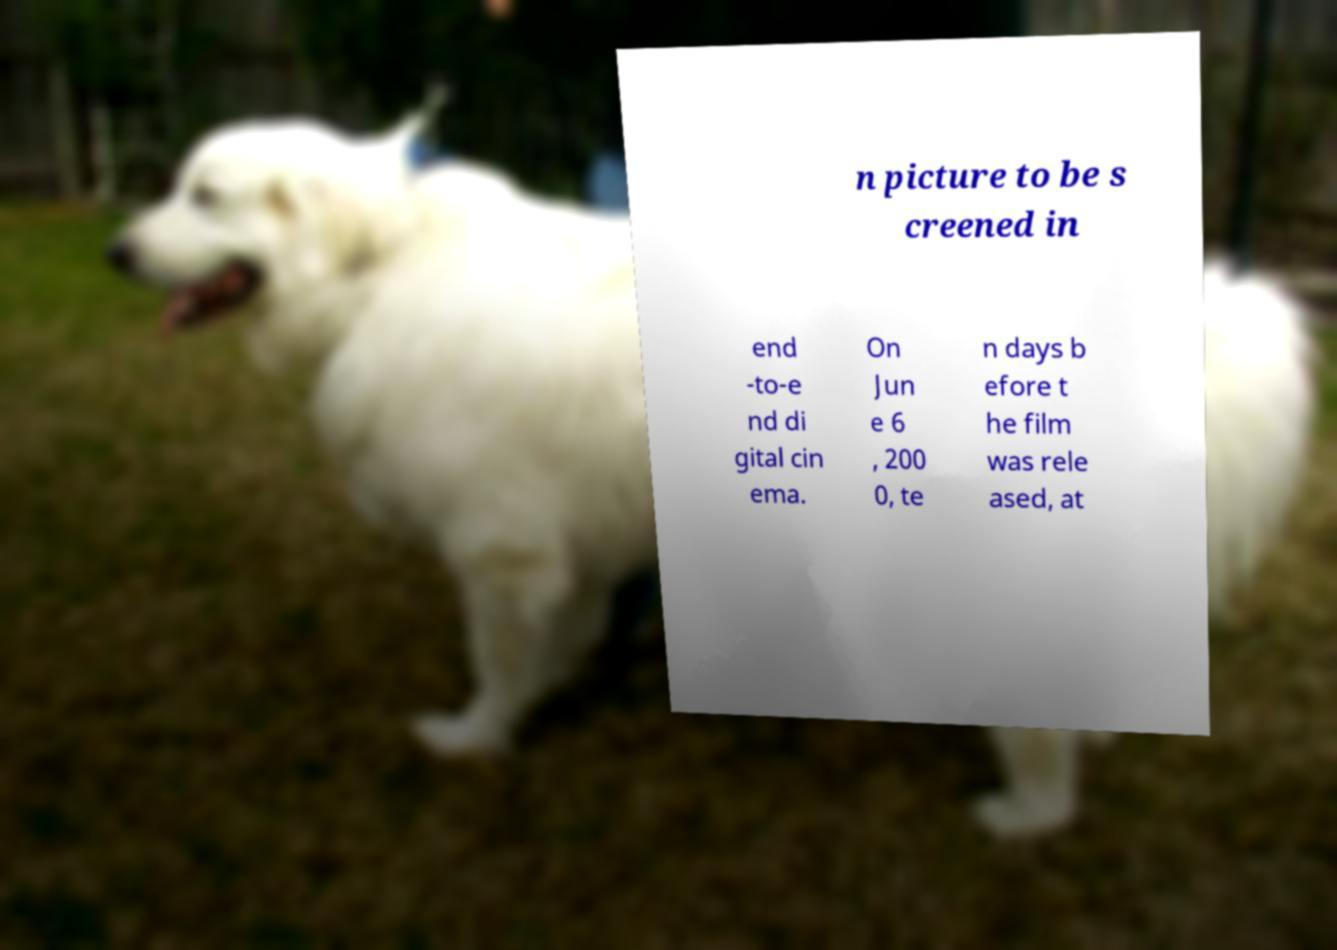Could you assist in decoding the text presented in this image and type it out clearly? n picture to be s creened in end -to-e nd di gital cin ema. On Jun e 6 , 200 0, te n days b efore t he film was rele ased, at 